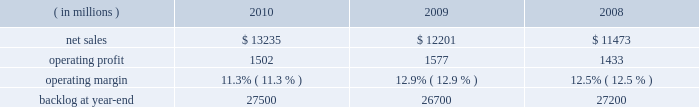The aeronautics segment generally includes fewer programs that have much larger sales and operating results than programs included in the other segments .
Due to the large number of comparatively smaller programs in the remaining segments , the discussion of the results of operations of those business segments focuses on lines of business within the segment rather than on specific programs .
The tables of financial information and related discussion of the results of operations of our business segments are consistent with the presentation of segment information in note 5 to the financial statements .
We have a number of programs that are classified by the u.s .
Government and cannot be specifically described .
The operating results of these classified programs are included in our consolidated and business segment results , and are subjected to the same oversight and internal controls as our other programs .
Aeronautics our aeronautics business segment is engaged in the research , design , development , manufacture , integration , sustainment , support , and upgrade of advanced military aircraft , including combat and air mobility aircraft , unmanned air vehicles , and related technologies .
Key combat aircraft programs include the f-35 lightning ii , f-16 fighting falcon , and f-22 raptor fighter aircraft .
Key air mobility programs include the c-130j super hercules and the c-5m super galaxy .
Aeronautics provides logistics support , sustainment , and upgrade modification services for its aircraft .
Aeronautics 2019 operating results included the following : ( in millions ) 2010 2009 2008 .
Net sales for aeronautics increased by 8% ( 8 % ) in 2010 compared to 2009 .
Sales increased in all three lines of business during the year .
The $ 800 million increase in air mobility primarily was attributable to higher volume on c-130 programs , including deliveries and support activities , as well as higher volume on the c-5 reliability enhancement and re-engining program ( rerp ) .
There were 25 c-130j deliveries in 2010 compared to 16 in 2009 .
The $ 179 million increase in combat aircraft principally was due to higher volume on f-35 production contracts , which partially was offset by lower volume on the f-35 sdd contract and a decline in volume on f-16 , f-22 and other combat aircraft programs .
There were 20 f-16 deliveries in 2010 compared to 31 in 2009 .
The $ 55 million increase in other aeronautics programs mainly was due to higher volume on p-3 and advanced development programs , which partially were offset by a decline in volume on sustainment activities .
Net sales for aeronautics increased by 6% ( 6 % ) in 2009 compared to 2008 .
During the year , sales increased in all three lines of business .
The increase of $ 296 million in air mobility 2019s sales primarily was attributable to higher volume on the c-130 programs , including deliveries and support activities .
There were 16 c-130j deliveries in 2009 and 12 in 2008 .
Combat aircraft sales increased $ 316 million principally due to higher volume on the f-35 program and increases in f-16 deliveries , which partially were offset by lower volume on f-22 and other combat aircraft programs .
There were 31 f-16 deliveries in 2009 compared to 28 in 2008 .
The $ 116 million increase in other aeronautics programs mainly was due to higher volume on p-3 programs and advanced development programs , which partially were offset by declines in sustainment activities .
Operating profit for the segment decreased by 5% ( 5 % ) in 2010 compared to 2009 .
A decline in operating profit in combat aircraft partially was offset by increases in other aeronautics programs and air mobility .
The $ 149 million decrease in combat aircraft 2019s operating profit primarily was due to lower volume and a decrease in the level of favorable performance adjustments on the f-22 program , the f-35 sdd contract and f-16 and other combat aircraft programs in 2010 .
These decreases more than offset increased operating profit resulting from higher volume and improved performance on f-35 production contracts in 2010 .
The $ 35 million increase in other aeronautics programs mainly was attributable to higher volume and improved performance on p-3 and advanced development programs as well as an increase in the level of favorable performance adjustments on sustainment activities in 2010 .
The $ 19 million increase in air mobility operating profit primarily was due to higher volume and improved performance in 2010 on c-130j support activities , which more than offset a decrease in operating profit due to a lower level of favorable performance adjustments on c-130j deliveries in 2010 .
The remaining change in operating profit is attributable to an increase in other income , net between the comparable periods .
Aeronautics 2019 2010 operating margins have decreased when compared to 2009 .
The operating margin decrease reflects the life cycles of our significant programs .
Specifically , aeronautics is performing more development and initial production work on the f-35 program and is performing less work on more mature programs such as the f-22 and f-16 .
Development and initial production contracts yield lower profits than mature full rate programs .
Accordingly , while net sales increased in 2010 relative to 2009 , operating profit decreased and consequently operating margins have declined. .
What were average net sales for aeronautics in millions from 2008 to 2010? 
Computations: table_average(net sales, none)
Answer: 12303.0. The aeronautics segment generally includes fewer programs that have much larger sales and operating results than programs included in the other segments .
Due to the large number of comparatively smaller programs in the remaining segments , the discussion of the results of operations of those business segments focuses on lines of business within the segment rather than on specific programs .
The tables of financial information and related discussion of the results of operations of our business segments are consistent with the presentation of segment information in note 5 to the financial statements .
We have a number of programs that are classified by the u.s .
Government and cannot be specifically described .
The operating results of these classified programs are included in our consolidated and business segment results , and are subjected to the same oversight and internal controls as our other programs .
Aeronautics our aeronautics business segment is engaged in the research , design , development , manufacture , integration , sustainment , support , and upgrade of advanced military aircraft , including combat and air mobility aircraft , unmanned air vehicles , and related technologies .
Key combat aircraft programs include the f-35 lightning ii , f-16 fighting falcon , and f-22 raptor fighter aircraft .
Key air mobility programs include the c-130j super hercules and the c-5m super galaxy .
Aeronautics provides logistics support , sustainment , and upgrade modification services for its aircraft .
Aeronautics 2019 operating results included the following : ( in millions ) 2010 2009 2008 .
Net sales for aeronautics increased by 8% ( 8 % ) in 2010 compared to 2009 .
Sales increased in all three lines of business during the year .
The $ 800 million increase in air mobility primarily was attributable to higher volume on c-130 programs , including deliveries and support activities , as well as higher volume on the c-5 reliability enhancement and re-engining program ( rerp ) .
There were 25 c-130j deliveries in 2010 compared to 16 in 2009 .
The $ 179 million increase in combat aircraft principally was due to higher volume on f-35 production contracts , which partially was offset by lower volume on the f-35 sdd contract and a decline in volume on f-16 , f-22 and other combat aircraft programs .
There were 20 f-16 deliveries in 2010 compared to 31 in 2009 .
The $ 55 million increase in other aeronautics programs mainly was due to higher volume on p-3 and advanced development programs , which partially were offset by a decline in volume on sustainment activities .
Net sales for aeronautics increased by 6% ( 6 % ) in 2009 compared to 2008 .
During the year , sales increased in all three lines of business .
The increase of $ 296 million in air mobility 2019s sales primarily was attributable to higher volume on the c-130 programs , including deliveries and support activities .
There were 16 c-130j deliveries in 2009 and 12 in 2008 .
Combat aircraft sales increased $ 316 million principally due to higher volume on the f-35 program and increases in f-16 deliveries , which partially were offset by lower volume on f-22 and other combat aircraft programs .
There were 31 f-16 deliveries in 2009 compared to 28 in 2008 .
The $ 116 million increase in other aeronautics programs mainly was due to higher volume on p-3 programs and advanced development programs , which partially were offset by declines in sustainment activities .
Operating profit for the segment decreased by 5% ( 5 % ) in 2010 compared to 2009 .
A decline in operating profit in combat aircraft partially was offset by increases in other aeronautics programs and air mobility .
The $ 149 million decrease in combat aircraft 2019s operating profit primarily was due to lower volume and a decrease in the level of favorable performance adjustments on the f-22 program , the f-35 sdd contract and f-16 and other combat aircraft programs in 2010 .
These decreases more than offset increased operating profit resulting from higher volume and improved performance on f-35 production contracts in 2010 .
The $ 35 million increase in other aeronautics programs mainly was attributable to higher volume and improved performance on p-3 and advanced development programs as well as an increase in the level of favorable performance adjustments on sustainment activities in 2010 .
The $ 19 million increase in air mobility operating profit primarily was due to higher volume and improved performance in 2010 on c-130j support activities , which more than offset a decrease in operating profit due to a lower level of favorable performance adjustments on c-130j deliveries in 2010 .
The remaining change in operating profit is attributable to an increase in other income , net between the comparable periods .
Aeronautics 2019 2010 operating margins have decreased when compared to 2009 .
The operating margin decrease reflects the life cycles of our significant programs .
Specifically , aeronautics is performing more development and initial production work on the f-35 program and is performing less work on more mature programs such as the f-22 and f-16 .
Development and initial production contracts yield lower profits than mature full rate programs .
Accordingly , while net sales increased in 2010 relative to 2009 , operating profit decreased and consequently operating margins have declined. .
What is the percentage change in operating income from 2009 to 2010? 
Computations: ((1502 - 1577) / 1577)
Answer: -0.04756. 